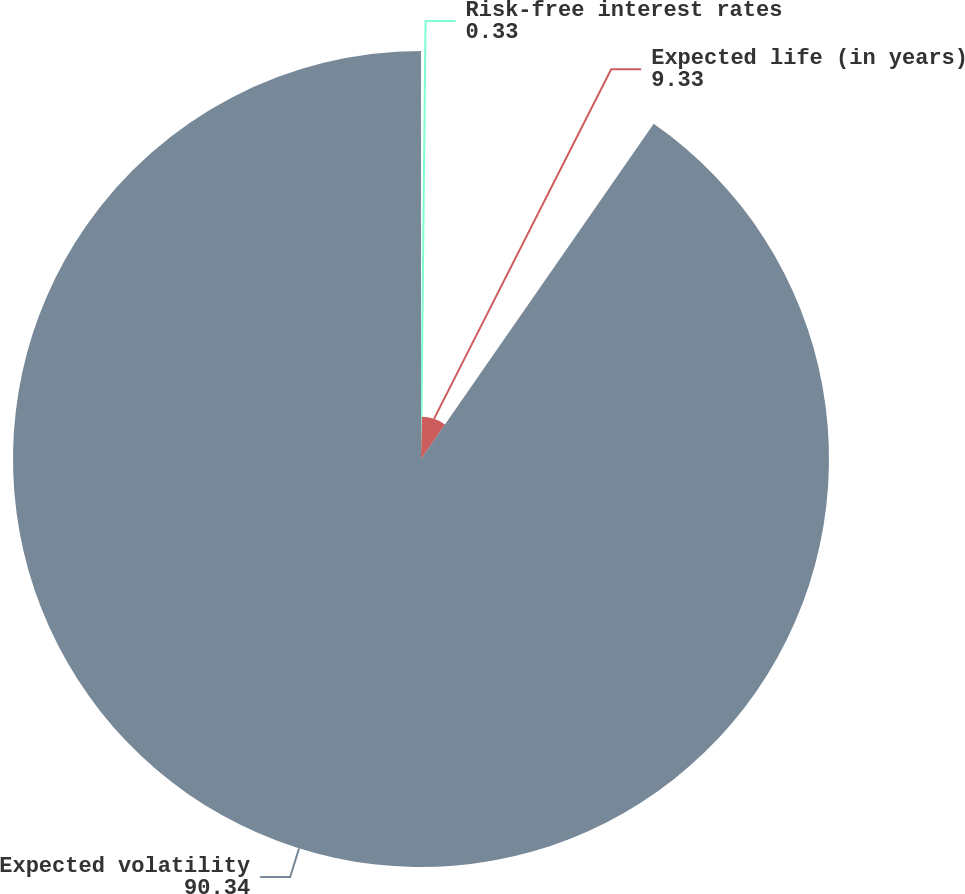<chart> <loc_0><loc_0><loc_500><loc_500><pie_chart><fcel>Risk-free interest rates<fcel>Expected life (in years)<fcel>Expected volatility<nl><fcel>0.33%<fcel>9.33%<fcel>90.34%<nl></chart> 